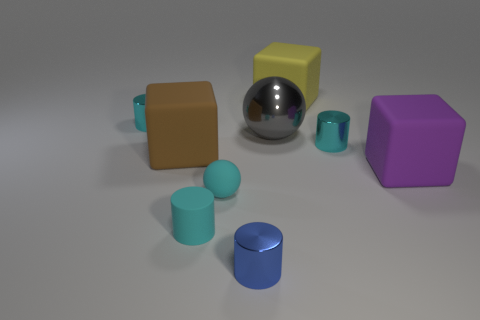Subtract all blue blocks. How many cyan cylinders are left? 3 Subtract 1 cylinders. How many cylinders are left? 3 Add 1 big shiny balls. How many objects exist? 10 Subtract all spheres. How many objects are left? 7 Subtract all green matte cylinders. Subtract all tiny cyan metallic cylinders. How many objects are left? 7 Add 3 cyan matte balls. How many cyan matte balls are left? 4 Add 7 metal blocks. How many metal blocks exist? 7 Subtract 1 brown cubes. How many objects are left? 8 